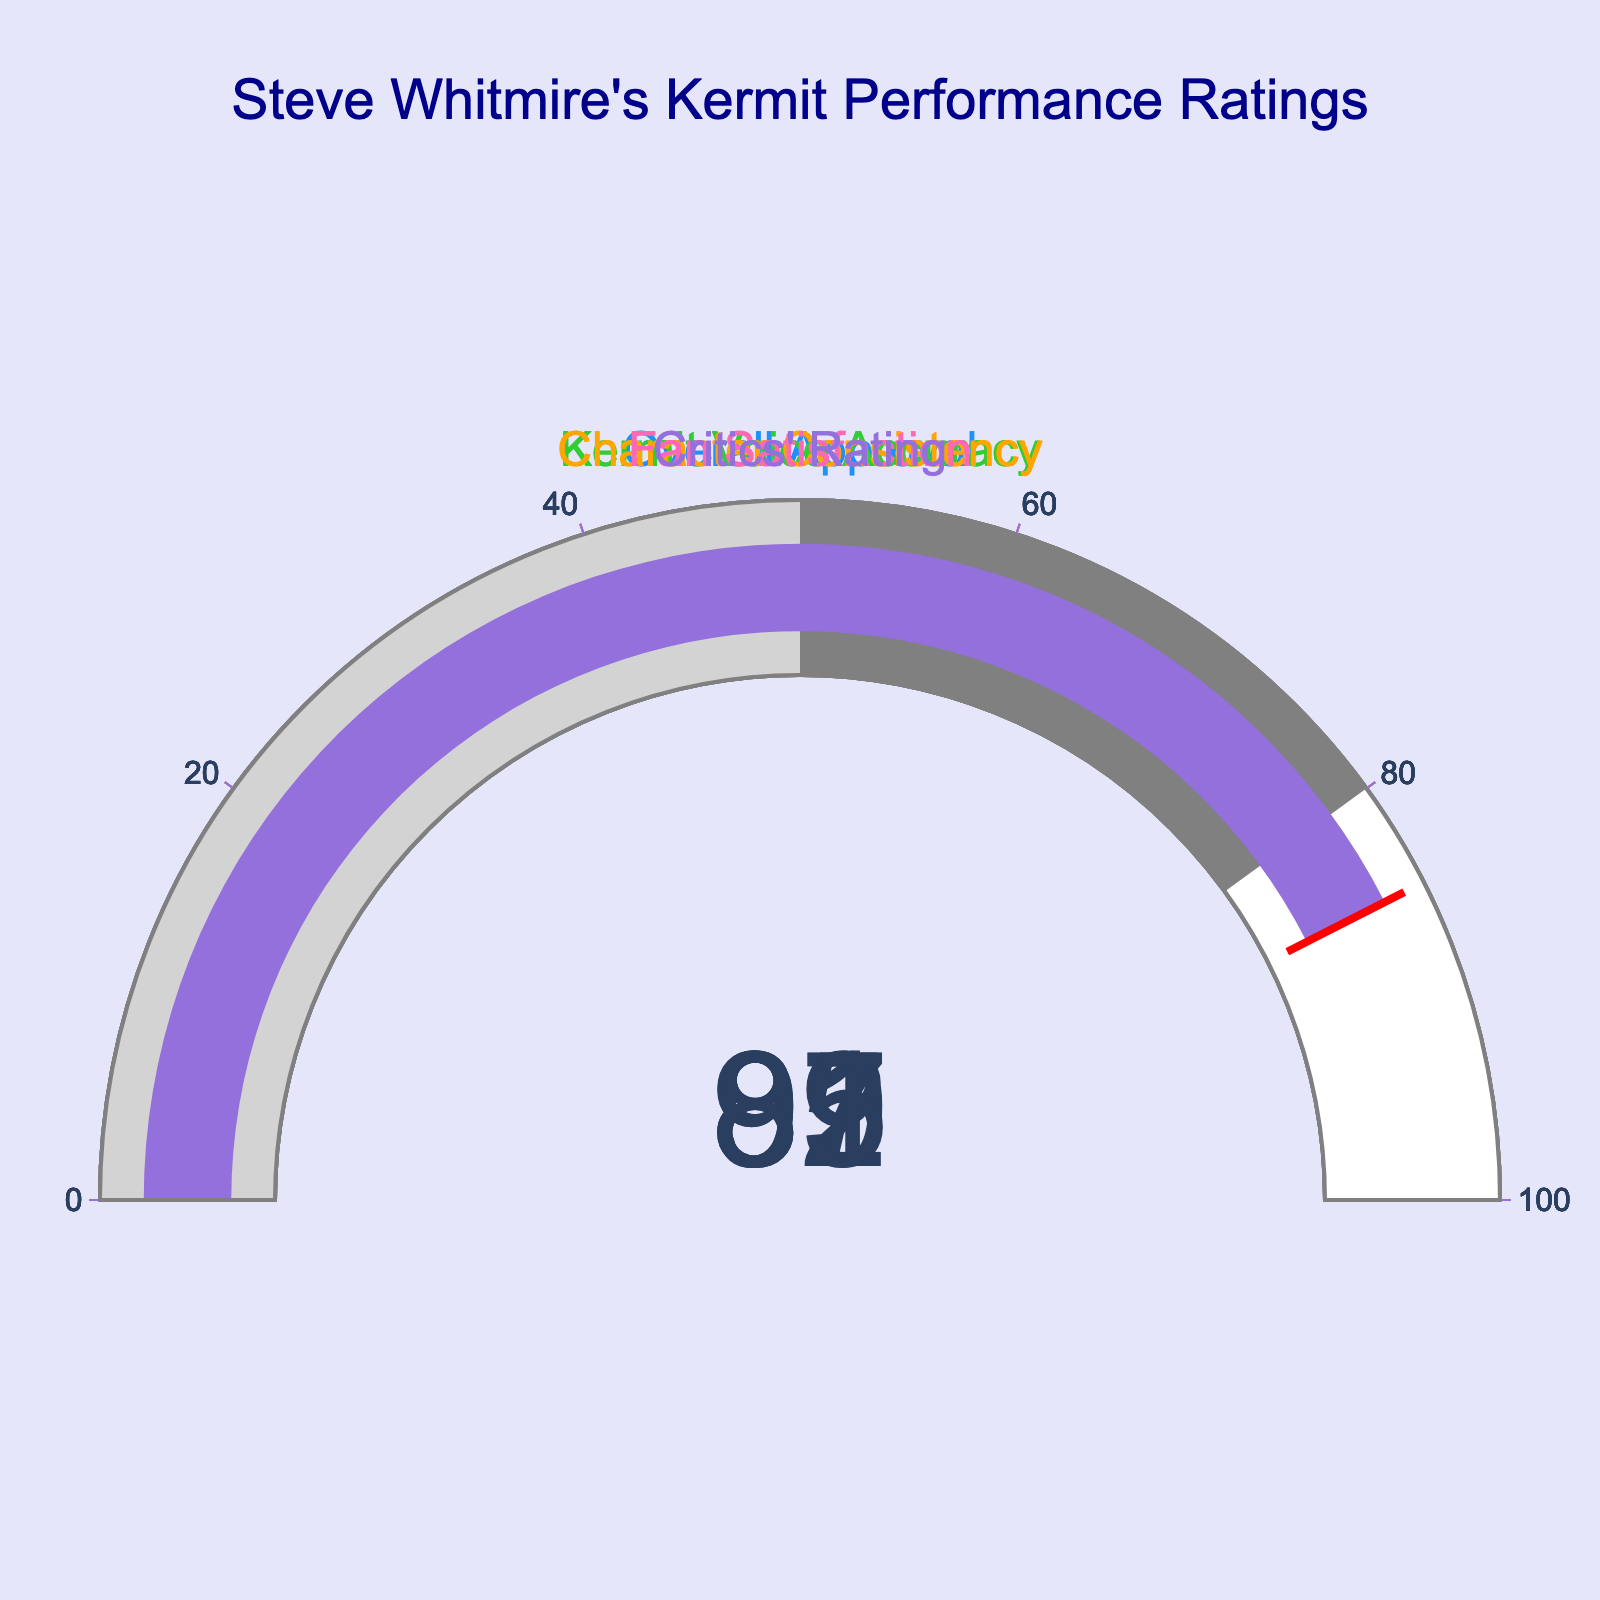What is the overall approval rating for Steve Whitmire's portrayal of Kermit the Frog? The overall approval rating is directly displayed on the gauge chart under "Overall Approval." It shows a value of 89.
Answer: 89 How accurate is Steve Whitmire's portrayal of Kermit's voice according to the ratings? The gauge chart labeled "Kermit Voice Accuracy" shows a value of 92, indicating his voice portrayal's accuracy.
Answer: 92 What is the difference between the "Critics' Rating" and the "Fan Satisfaction" values? To find the difference, subtract the "Critics' Rating" (85) from "Fan Satisfaction" (91). 91 - 85 = 6.
Answer: 6 Which category has the lowest rating? By comparing all the displayed ratings, "Critics' Rating" has the lowest value of 85.
Answer: Critics' Rating What is the average rating across all five categories? Sum all the values and divide by the number of categories: (89 + 92 + 87 + 91 + 85) / 5 = 88.8.
Answer: 88.8 Which category shows the highest satisfaction? The highest value among all categories is 92 for "Kermit Voice Accuracy."
Answer: Kermit Voice Accuracy Is the "Character Consistency" rating above or below 90? The "Character Consistency" gauge shows a rating of 87, which is below 90.
Answer: Below If the "Overall Approval" was increased by 5 points, what would the new approval rating be? Add 5 to the current overall approval rating: 89 + 5 = 94.
Answer: 94 Are all categories rated above 80? The lowest rating is 85 for "Critics' Rating," which is above 80, thus all categories are rated above 80.
Answer: Yes How much higher is the "Fan Satisfaction" rating compared to the "Character Consistency" rating? Subtract "Character Consistency" (87) from "Fan Satisfaction" (91). 91 - 87 = 4.
Answer: 4 